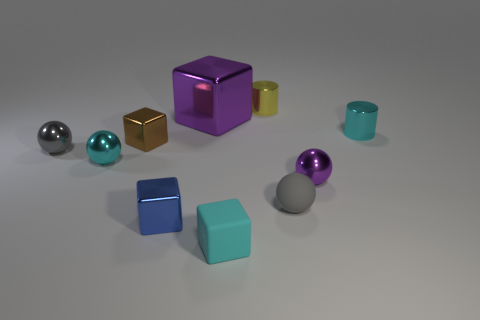Subtract all tiny cyan balls. How many balls are left? 3 Subtract all cyan cubes. How many cubes are left? 3 Subtract all spheres. How many objects are left? 6 Subtract 4 cubes. How many cubes are left? 0 Add 7 cyan matte things. How many cyan matte things are left? 8 Add 6 small cylinders. How many small cylinders exist? 8 Subtract 0 red spheres. How many objects are left? 10 Subtract all brown cylinders. Subtract all brown balls. How many cylinders are left? 2 Subtract all blue cylinders. How many green spheres are left? 0 Subtract all small brown blocks. Subtract all purple metal balls. How many objects are left? 8 